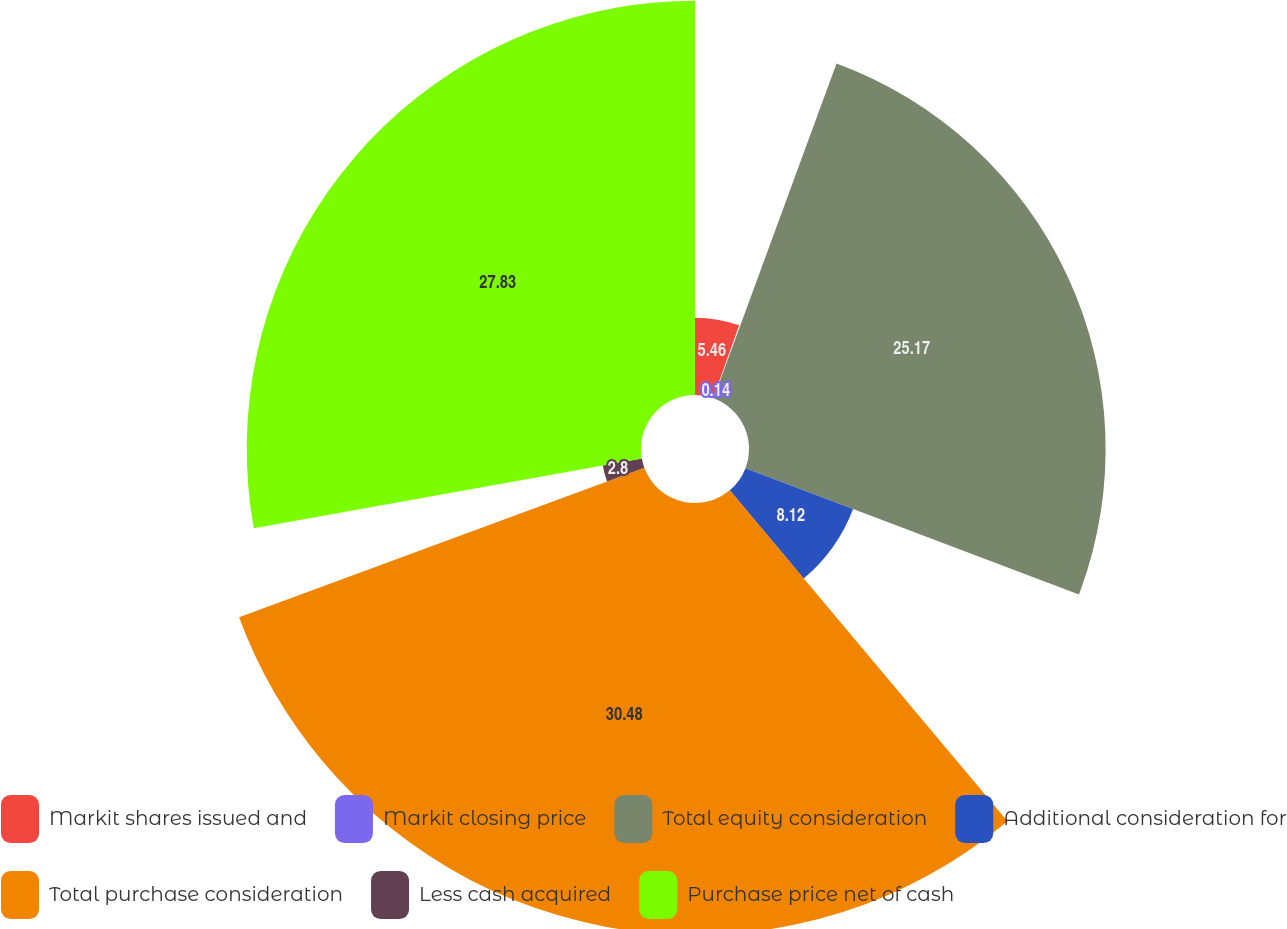Convert chart to OTSL. <chart><loc_0><loc_0><loc_500><loc_500><pie_chart><fcel>Markit shares issued and<fcel>Markit closing price<fcel>Total equity consideration<fcel>Additional consideration for<fcel>Total purchase consideration<fcel>Less cash acquired<fcel>Purchase price net of cash<nl><fcel>5.46%<fcel>0.14%<fcel>25.17%<fcel>8.12%<fcel>30.49%<fcel>2.8%<fcel>27.83%<nl></chart> 